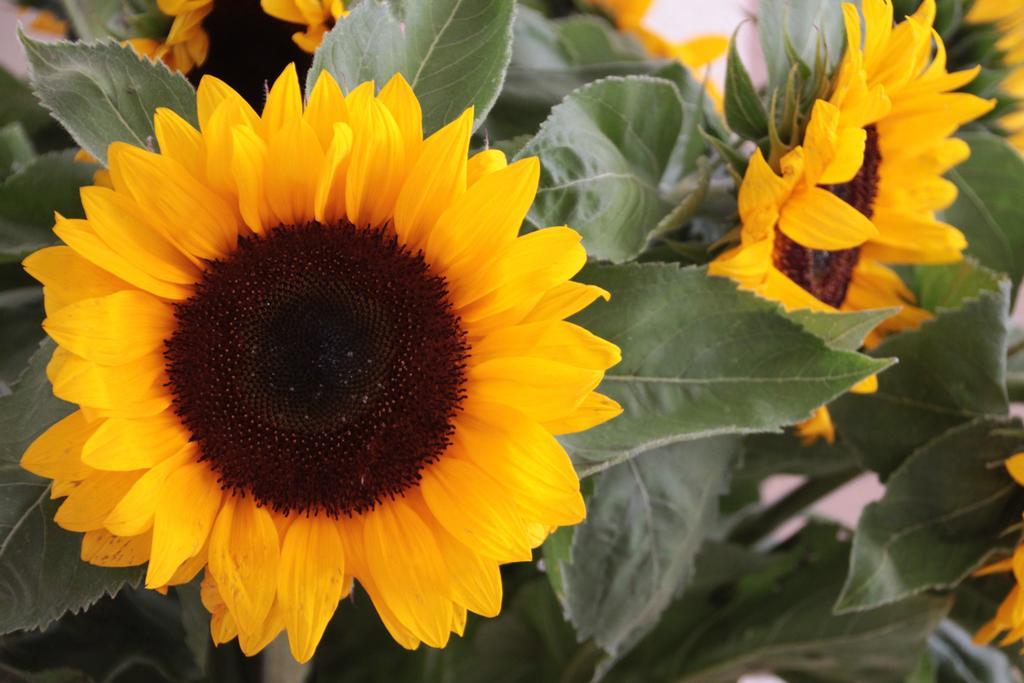Could you give a brief overview of what you see in this image? In this image we can see sunflowers and leaves. 